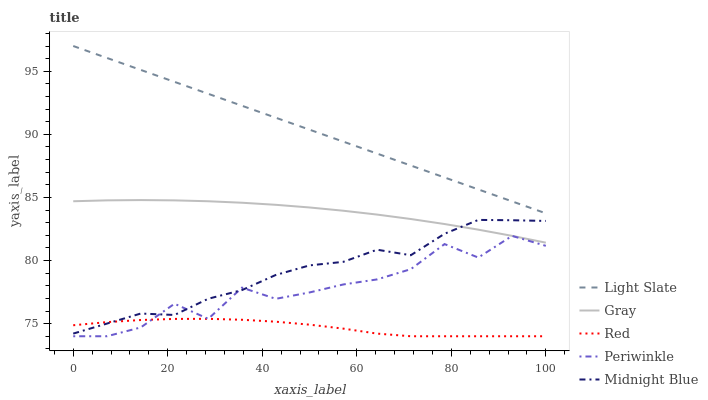Does Red have the minimum area under the curve?
Answer yes or no. Yes. Does Light Slate have the maximum area under the curve?
Answer yes or no. Yes. Does Gray have the minimum area under the curve?
Answer yes or no. No. Does Gray have the maximum area under the curve?
Answer yes or no. No. Is Light Slate the smoothest?
Answer yes or no. Yes. Is Periwinkle the roughest?
Answer yes or no. Yes. Is Gray the smoothest?
Answer yes or no. No. Is Gray the roughest?
Answer yes or no. No. Does Gray have the lowest value?
Answer yes or no. No. Does Gray have the highest value?
Answer yes or no. No. Is Red less than Gray?
Answer yes or no. Yes. Is Gray greater than Red?
Answer yes or no. Yes. Does Red intersect Gray?
Answer yes or no. No. 